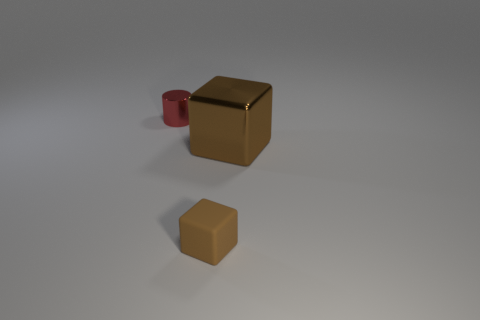Is there anything else that is the same size as the brown metallic cube?
Your answer should be compact. No. Is the small rubber object the same shape as the large object?
Your response must be concise. Yes. The object that is behind the tiny brown block and on the left side of the large object is made of what material?
Your answer should be compact. Metal. How many other things are the same shape as the brown matte thing?
Ensure brevity in your answer.  1. What size is the metal object that is behind the brown block that is behind the thing in front of the large cube?
Provide a succinct answer. Small. Is the number of brown blocks behind the brown shiny thing greater than the number of purple shiny objects?
Keep it short and to the point. No. Are there any large shiny things?
Offer a very short reply. Yes. What number of red metallic cylinders are the same size as the brown shiny object?
Offer a terse response. 0. Are there more large brown cubes right of the matte object than small rubber things that are on the left side of the small cylinder?
Offer a very short reply. Yes. There is a cylinder that is the same size as the rubber block; what is its material?
Provide a short and direct response. Metal. 